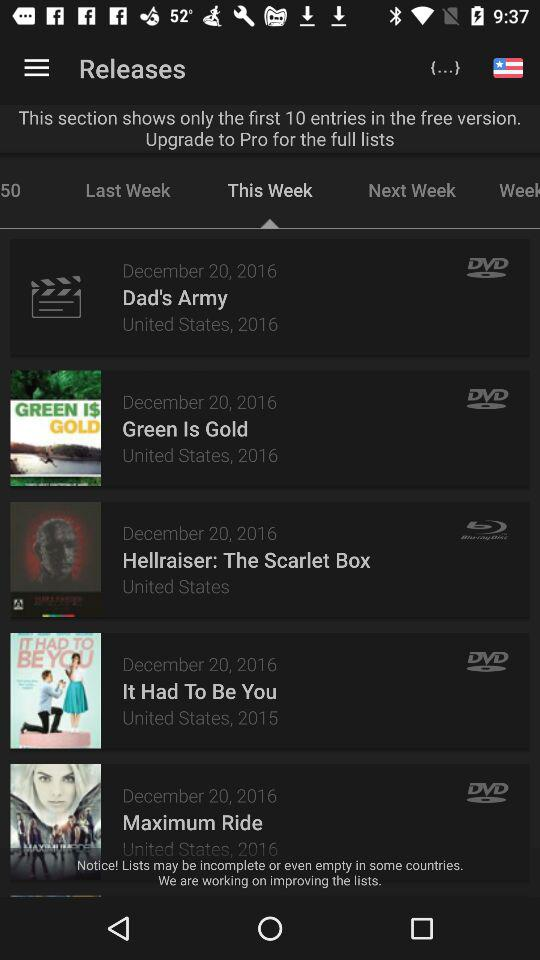In what country was "Maximum Ride" released? "Maximum Ride" was released in the United States. 